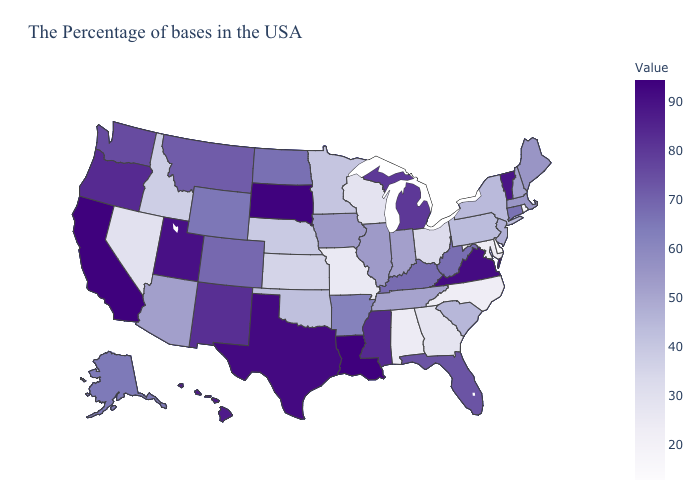Among the states that border Georgia , which have the lowest value?
Write a very short answer. North Carolina. Does Louisiana have the highest value in the USA?
Give a very brief answer. Yes. Among the states that border Tennessee , which have the highest value?
Quick response, please. Virginia. Among the states that border Mississippi , does Louisiana have the highest value?
Keep it brief. Yes. Which states have the highest value in the USA?
Write a very short answer. Louisiana. Which states have the lowest value in the USA?
Be succinct. Delaware. 